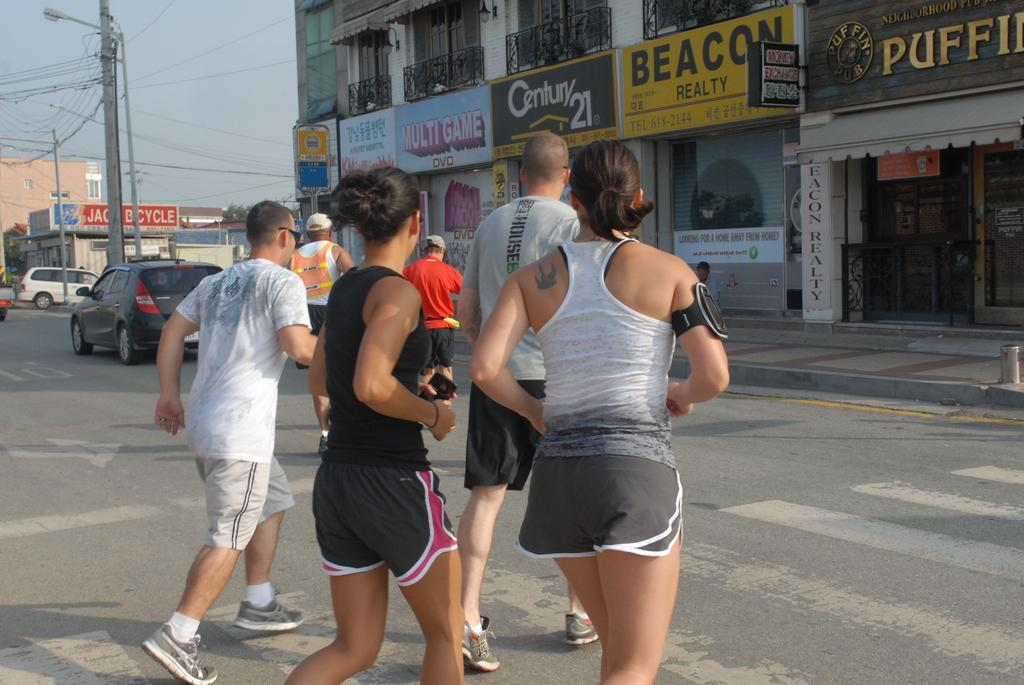<image>
Give a short and clear explanation of the subsequent image. A group of two male joggers and two female joggers run across a street toward Beacon Realty. 